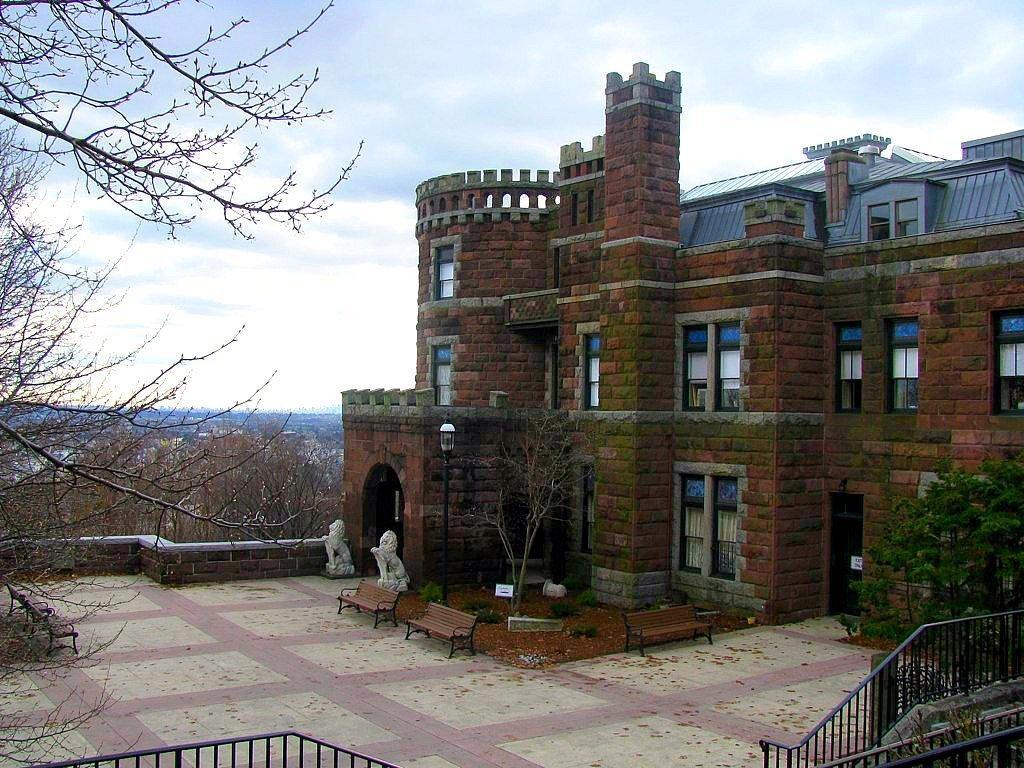How would you summarize this image in a sentence or two? This picture shows a building and we see trees and a blue cloudy Sky and couple of benches. 